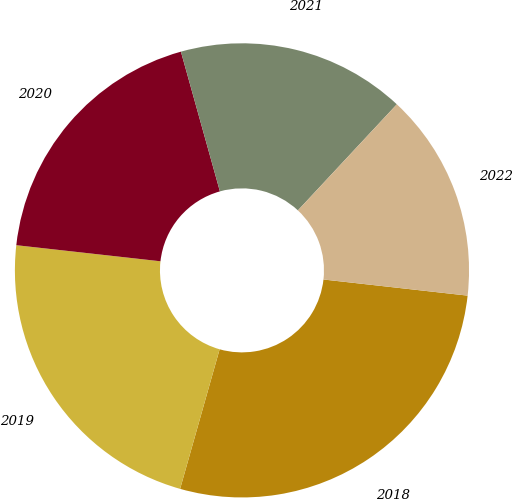Convert chart. <chart><loc_0><loc_0><loc_500><loc_500><pie_chart><fcel>2018<fcel>2019<fcel>2020<fcel>2021<fcel>2022<nl><fcel>27.62%<fcel>22.38%<fcel>18.9%<fcel>16.28%<fcel>14.83%<nl></chart> 